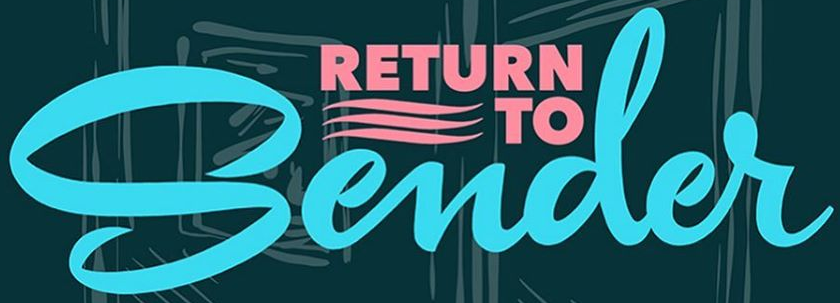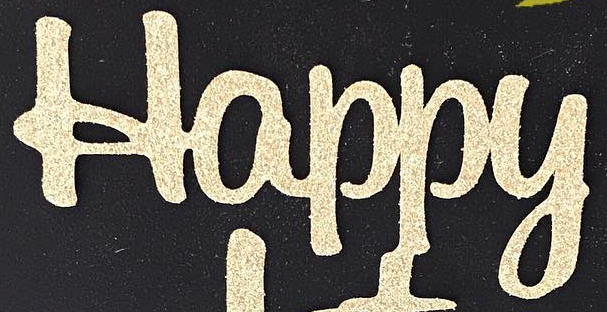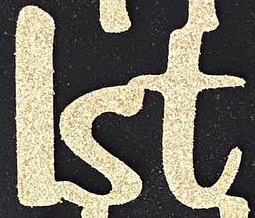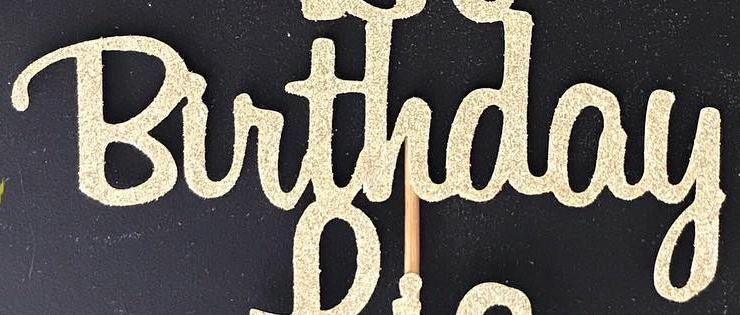What text appears in these images from left to right, separated by a semicolon? Sender; Happy; lst; Birthday 